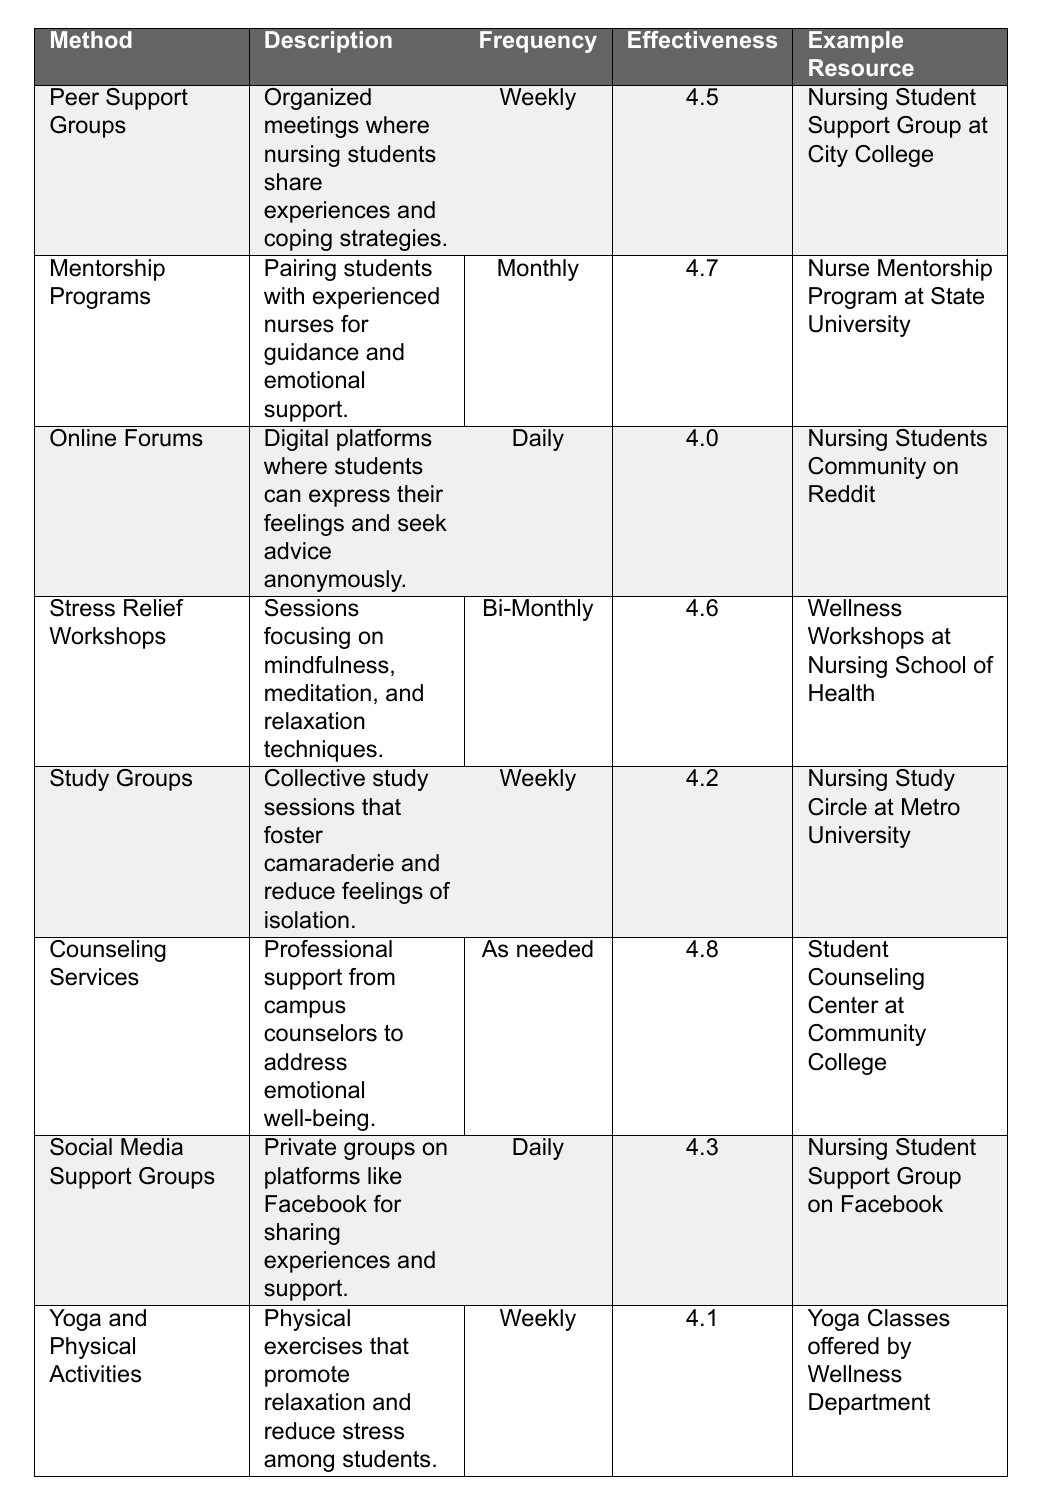What is the effectiveness rating of Counseling Services? The table lists Counseling Services with an effectiveness rating of 4.8.
Answer: 4.8 How often do Yoga and Physical Activities occur? The frequency for Yoga and Physical Activities is listed as Weekly in the table.
Answer: Weekly Which emotional support method has the highest effectiveness rating? Looking through the effectiveness ratings, Counseling Services has the highest rating of 4.8.
Answer: Counseling Services Are Peer Support Groups held daily? The table indicates that Peer Support Groups are held weekly, not daily.
Answer: No What is the average effectiveness rating for all methods listed in the table? To find the average, we add all effectiveness ratings: (4.5 + 4.7 + 4.0 + 4.6 + 4.2 + 4.8 + 4.3 + 4.1) = 34.2; then we divide by the number of methods (8), yielding an average of 34.2/8 = 4.275.
Answer: 4.275 Is there a method that occurs Bi-Monthly? Yes, Stress Relief Workshops are listed as occurring Bi-Monthly in the table.
Answer: Yes How do the frequencies of Online Forums and Social Media Support Groups compare? Both Online Forums and Social Media Support Groups occur daily, so their frequencies are the same.
Answer: They occur daily What is the difference between the highest and lowest effectiveness ratings? The highest effectiveness rating is 4.8 (Counseling Services) and the lowest is 4.0 (Online Forums). The difference is 4.8 - 4.0 = 0.8.
Answer: 0.8 Which support method combines physical activity with emotional support? The method Yoga and Physical Activities combines physical activity with emotional support, as indicated in the description of the table.
Answer: Yoga and Physical Activities Between Mentorship Programs and Study Groups, which has a higher effectiveness rating? Mentorship Programs have an effectiveness rating of 4.7, while Study Groups have 4.2, making Mentorship Programs higher.
Answer: Mentorship Programs 